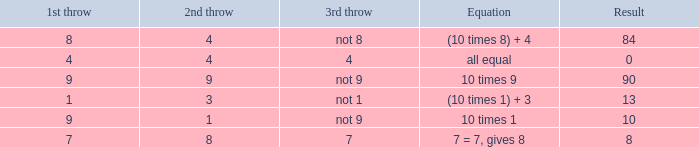What is the result when the 3rd throw is not 8? 84.0. 